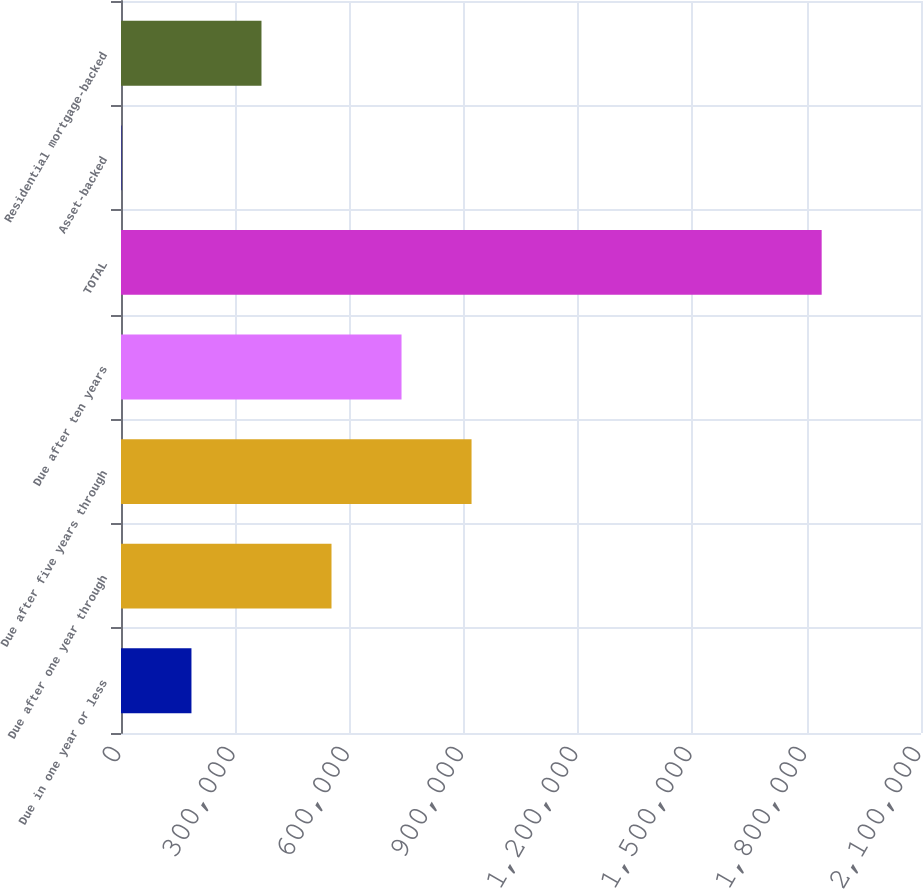Convert chart to OTSL. <chart><loc_0><loc_0><loc_500><loc_500><bar_chart><fcel>Due in one year or less<fcel>Due after one year through<fcel>Due after five years through<fcel>Due after ten years<fcel>TOTAL<fcel>Asset-backed<fcel>Residential mortgage-backed<nl><fcel>184947<fcel>552570<fcel>920192<fcel>736381<fcel>1.83925e+06<fcel>1136<fcel>368759<nl></chart> 